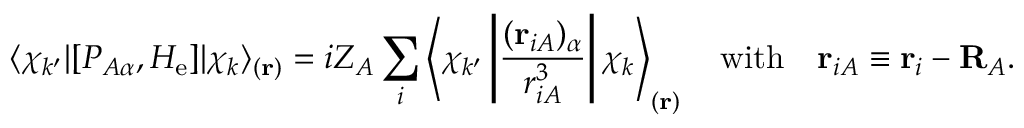Convert formula to latex. <formula><loc_0><loc_0><loc_500><loc_500>\langle \chi _ { k ^ { \prime } } | [ P _ { A \alpha } , H _ { e } ] | \chi _ { k } \rangle _ { ( r ) } = i Z _ { A } \sum _ { i } \left \langle \chi _ { k ^ { \prime } } \left | { \frac { ( r _ { i A } ) _ { \alpha } } { r _ { i A } ^ { 3 } } } \right | \chi _ { k } \right \rangle _ { ( r ) } \quad w i t h \quad r _ { i A } \equiv r _ { i } - R _ { A } .</formula> 